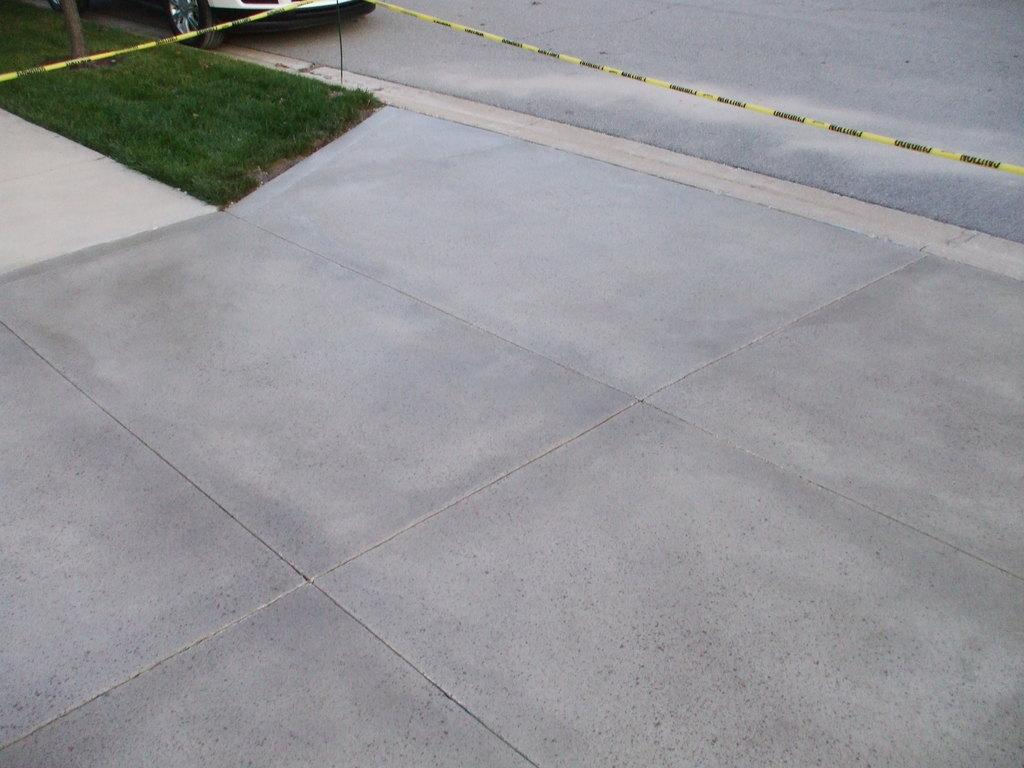What type of surface can be seen in the image? There is a granite floor in the image. What is the main feature of the image? There is a road in the image. Where is the car located in the image? The car is near the grass in the top left corner of the image. What type of expansion is taking place in the image? There is no expansion taking place in the image; it is a still image. 